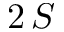<formula> <loc_0><loc_0><loc_500><loc_500>2 \, S</formula> 